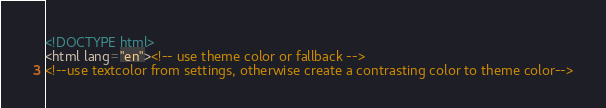<code> <loc_0><loc_0><loc_500><loc_500><_HTML_><!DOCTYPE html>
<html lang="en"><!-- use theme color or fallback -->
<!--use textcolor from settings, otherwise create a contrasting color to theme color--></code> 